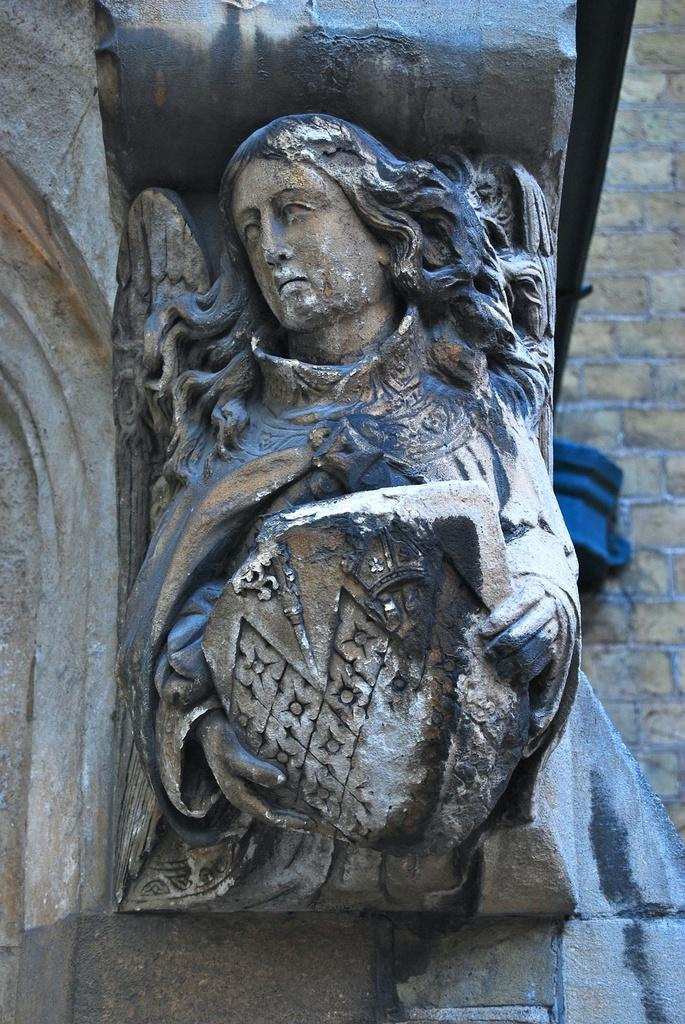What is the main subject of the image? There is a sculpture of a woman in the image. Can you describe the background of the image? There is a blue color thing and a wall in the background of the image. What is the purpose of the ghost in the image? There is no ghost present in the image. 